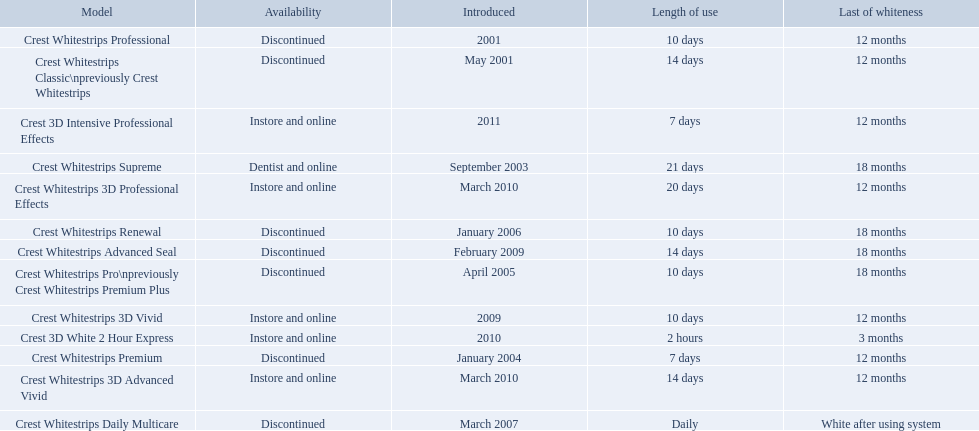Which of these products are discontinued? Crest Whitestrips Classic\npreviously Crest Whitestrips, Crest Whitestrips Professional, Crest Whitestrips Premium, Crest Whitestrips Pro\npreviously Crest Whitestrips Premium Plus, Crest Whitestrips Renewal, Crest Whitestrips Daily Multicare, Crest Whitestrips Advanced Seal. Which of these products have a 14 day length of use? Crest Whitestrips Classic\npreviously Crest Whitestrips, Crest Whitestrips Advanced Seal. Which of these products was introduced in 2009? Crest Whitestrips Advanced Seal. Which models are still available? Crest Whitestrips Supreme, Crest Whitestrips 3D Vivid, Crest Whitestrips 3D Advanced Vivid, Crest Whitestrips 3D Professional Effects, Crest 3D White 2 Hour Express, Crest 3D Intensive Professional Effects. Of those, which were introduced prior to 2011? Crest Whitestrips Supreme, Crest Whitestrips 3D Vivid, Crest Whitestrips 3D Advanced Vivid, Crest Whitestrips 3D Professional Effects, Crest 3D White 2 Hour Express. Among those models, which ones had to be used at least 14 days? Crest Whitestrips Supreme, Crest Whitestrips 3D Advanced Vivid, Crest Whitestrips 3D Professional Effects. Which of those lasted longer than 12 months? Crest Whitestrips Supreme. 